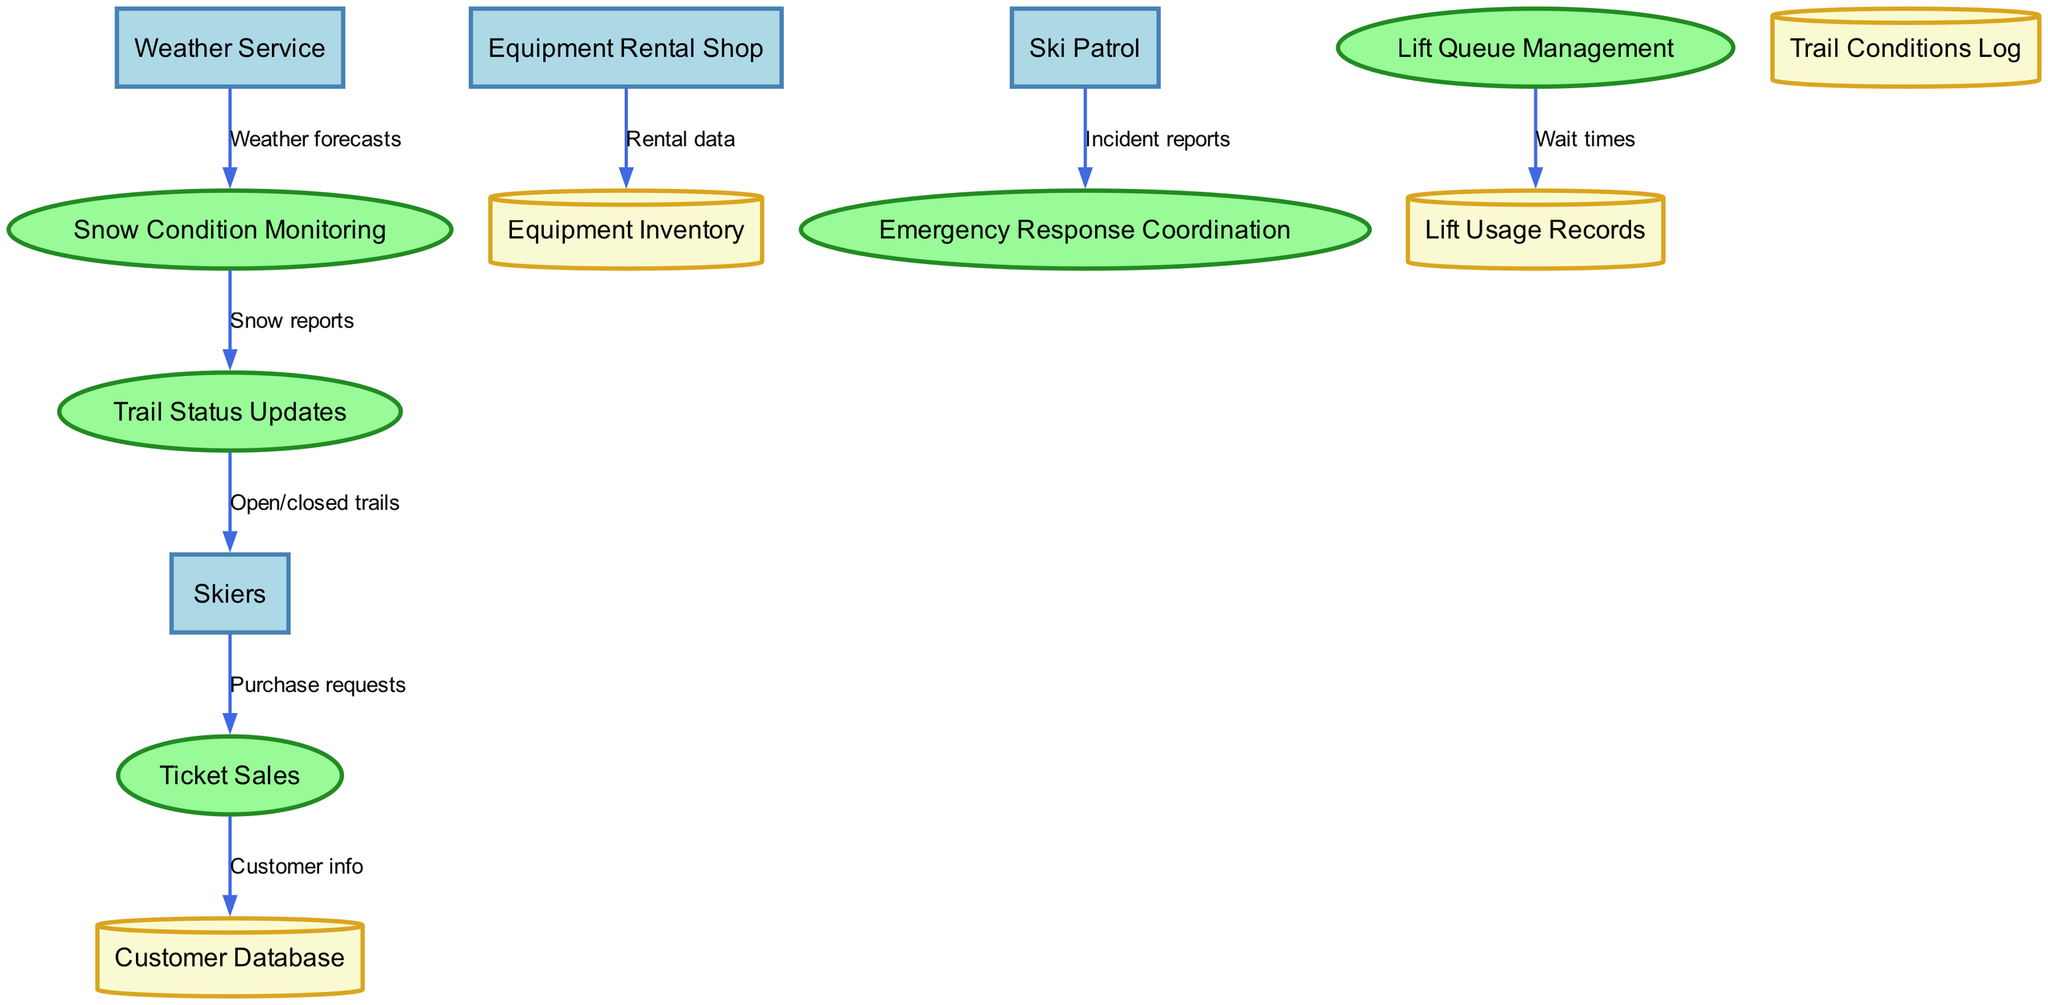What are the external entities involved in the diagram? The external entities can be found listed at the top of the diagram. They include "Skiers," "Weather Service," "Equipment Rental Shop," and "Ski Patrol."
Answer: Skiers, Weather Service, Equipment Rental Shop, Ski Patrol How many processes are represented in the diagram? The processes are displayed as oval shapes in the center of the diagram. There are five processes: "Ticket Sales," "Lift Queue Management," "Snow Condition Monitoring," "Trail Status Updates," and "Emergency Response Coordination."
Answer: Five What is the flow from "Skiers" to "Ticket Sales"? The flow from "Skiers" to "Ticket Sales" is indicated by an arrow labeled "Purchase requests" that shows Skiers making requests for tickets to the Ticket Sales process.
Answer: Purchase requests Which process is linked to both the "Snow Condition Monitoring" and "Trail Status Updates"? The process "Snow Condition Monitoring" is linked to "Trail Status Updates". The arrow indicates that reports on snow conditions are sent to update trails' status.
Answer: Snow Condition Monitoring What type of data does the "Equipment Rental Shop" send to the "Equipment Inventory"? The data being sent is labeled as "Rental data," which specifies what is transferred from the Equipment Rental Shop to the Equipment Inventory.
Answer: Rental data How many data stores are included within the diagram? The data stores are represented as cylindrical shapes. There are four data stores named: "Customer Database," "Lift Usage Records," "Trail Conditions Log," and "Equipment Inventory."
Answer: Four What does the "Weather Service" provide to the "Snow Condition Monitoring"? The "Weather Service" contributes "Weather forecasts," which is the information provided to the "Snow Condition Monitoring" process to assess current skiing conditions.
Answer: Weather forecasts What is the purpose of the flow from "Ski Patrol" to "Emergency Response Coordination"? The flow specifies "Incident reports" from Ski Patrol to Emergency Response Coordination, indicating that Ski Patrol shares information about incidents that require emergency action.
Answer: Incident reports How do "Trail Status Updates" affect "Skiers"? The arrow from "Trail Status Updates" to "Skiers" is labeled "Open/closed trails," indicating that trail status updates inform skiers on which trails are available for skiing.
Answer: Open/closed trails 